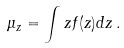Convert formula to latex. <formula><loc_0><loc_0><loc_500><loc_500>\mu _ { z } = \int z f ( z ) d z \, .</formula> 